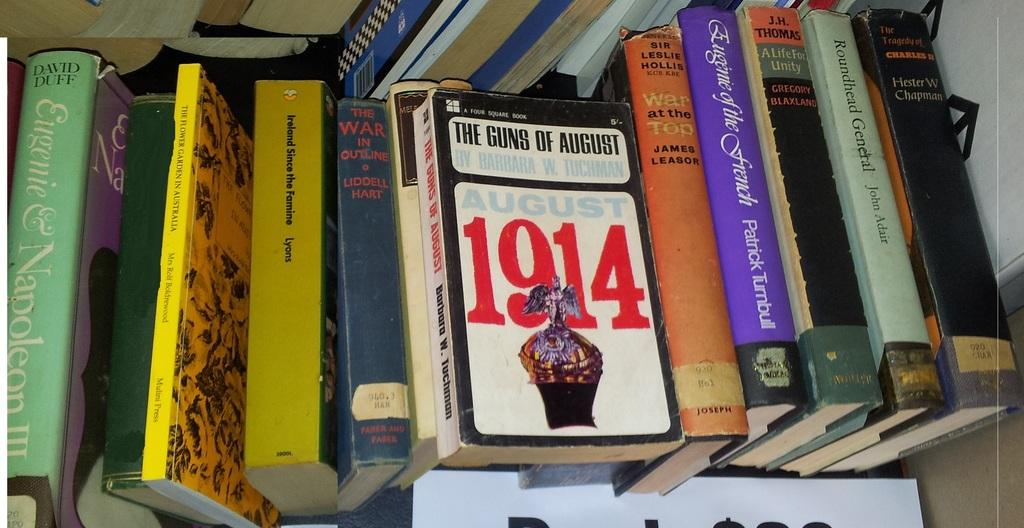<image>
Share a concise interpretation of the image provided. a bunch of books and one is titled 1914 